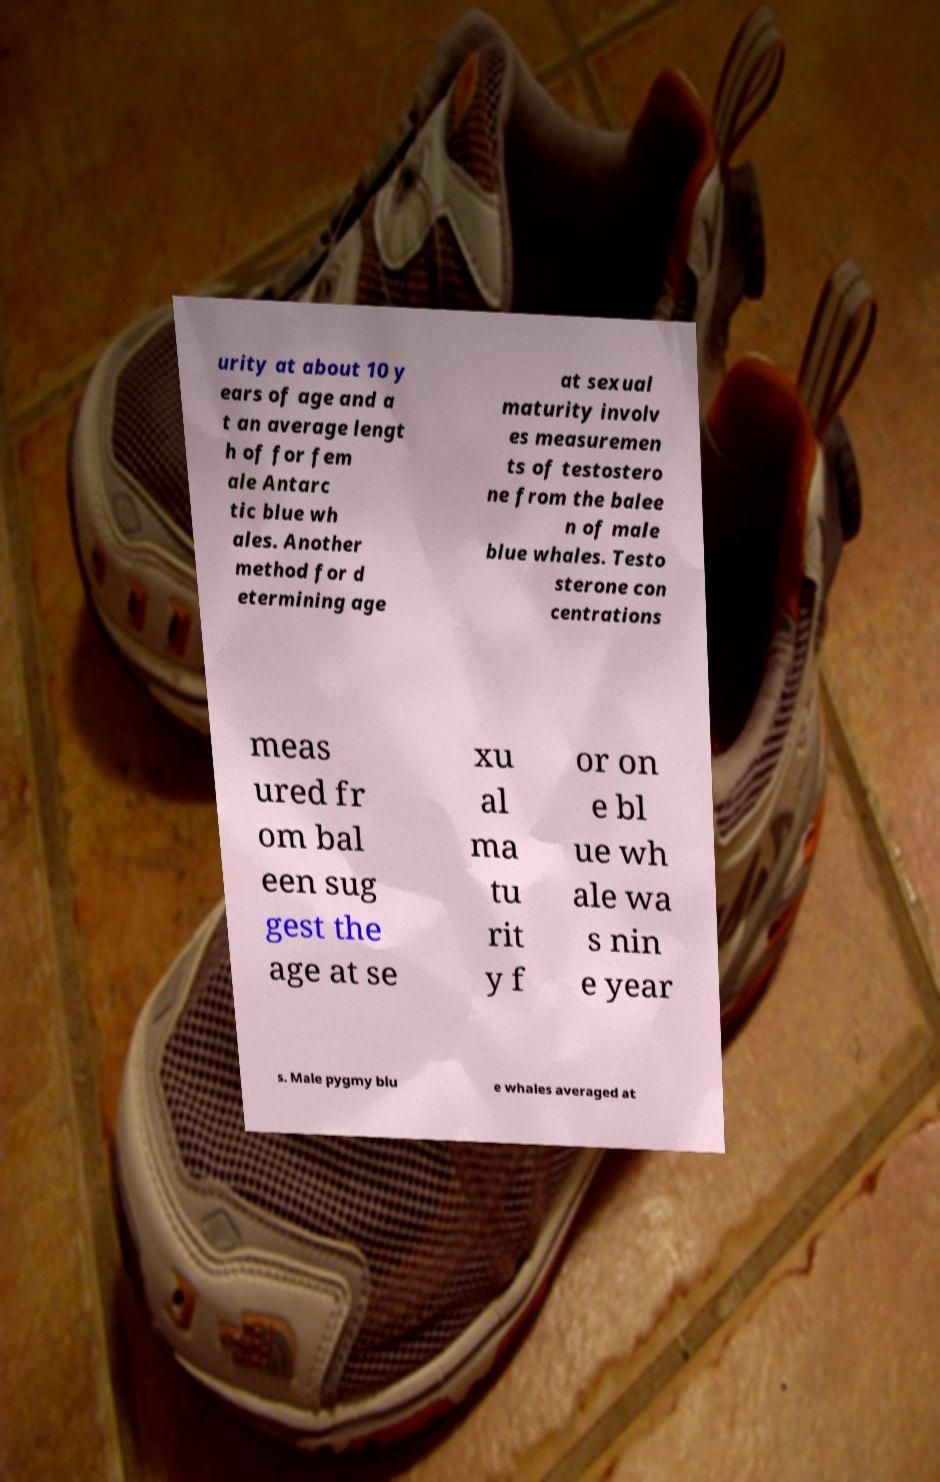There's text embedded in this image that I need extracted. Can you transcribe it verbatim? urity at about 10 y ears of age and a t an average lengt h of for fem ale Antarc tic blue wh ales. Another method for d etermining age at sexual maturity involv es measuremen ts of testostero ne from the balee n of male blue whales. Testo sterone con centrations meas ured fr om bal een sug gest the age at se xu al ma tu rit y f or on e bl ue wh ale wa s nin e year s. Male pygmy blu e whales averaged at 